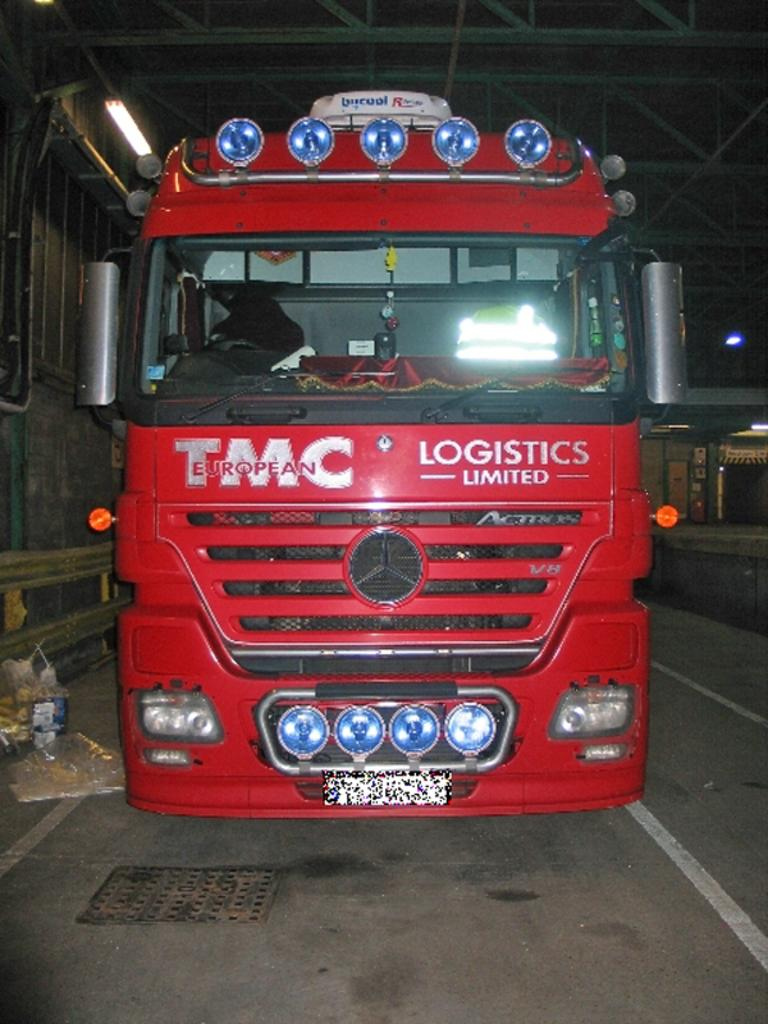What is the color of the vehicle in the image? The vehicle in the image is red. Where is the vehicle located? The vehicle is on the road. What else can be seen in the image besides the vehicle? There are lights visible in the image. What type of structure is present at the top of the image? There is a roof for shelter at the top of the image. How many cattle can be seen grazing near the vehicle in the image? There are no cattle present in the image. What type of impulse is being measured by the lights in the image? The lights in the image do not measure any impulses; they are simply visible. What is the quiver used for in the image? There is no quiver present in the image. 